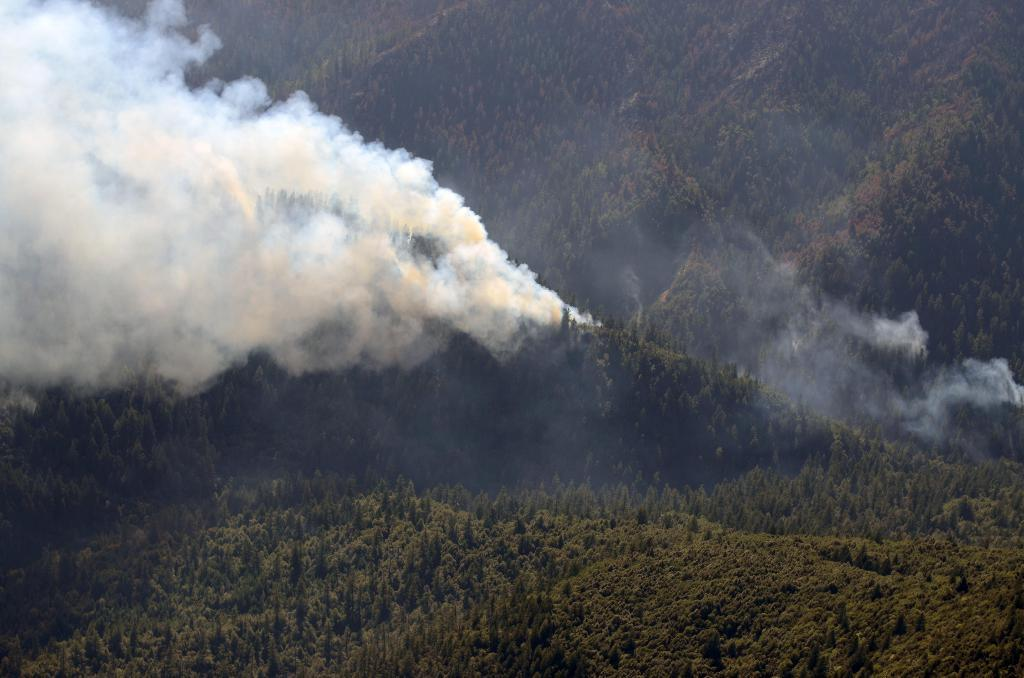What type of natural features can be seen at the bottom of the image? There are trees and plants on a hill at the bottom of the image. What can be seen on the left side of the image? There is smoke on the left side of the image. What can be seen on the right side of the image? There is smoke on the right side of the image. What type of landscape is visible in the background of the image? There are mountains in the background of the image. What type of stick can be seen being used in a protest in the image? There is no stick or protest present in the image. What type of border is visible between the trees and plants on the hill and the mountains in the background? There is no border visible between the trees and plants on the hill and the mountains in the background; the image shows a continuous landscape. 